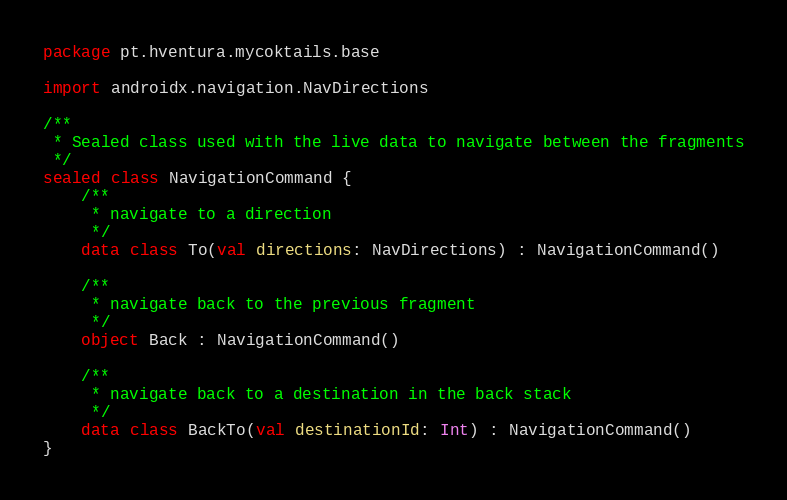Convert code to text. <code><loc_0><loc_0><loc_500><loc_500><_Kotlin_>package pt.hventura.mycoktails.base

import androidx.navigation.NavDirections

/**
 * Sealed class used with the live data to navigate between the fragments
 */
sealed class NavigationCommand {
    /**
     * navigate to a direction
     */
    data class To(val directions: NavDirections) : NavigationCommand()

    /**
     * navigate back to the previous fragment
     */
    object Back : NavigationCommand()

    /**
     * navigate back to a destination in the back stack
     */
    data class BackTo(val destinationId: Int) : NavigationCommand()
}</code> 